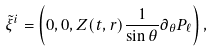Convert formula to latex. <formula><loc_0><loc_0><loc_500><loc_500>\tilde { \xi } ^ { i } = \left ( 0 , 0 , Z ( t , r ) \frac { 1 } { \sin \theta } \partial _ { \theta } P _ { \ell } \right ) ,</formula> 